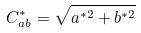<formula> <loc_0><loc_0><loc_500><loc_500>C _ { a b } ^ { * } = \sqrt { a ^ { * 2 } + b ^ { * 2 } }</formula> 